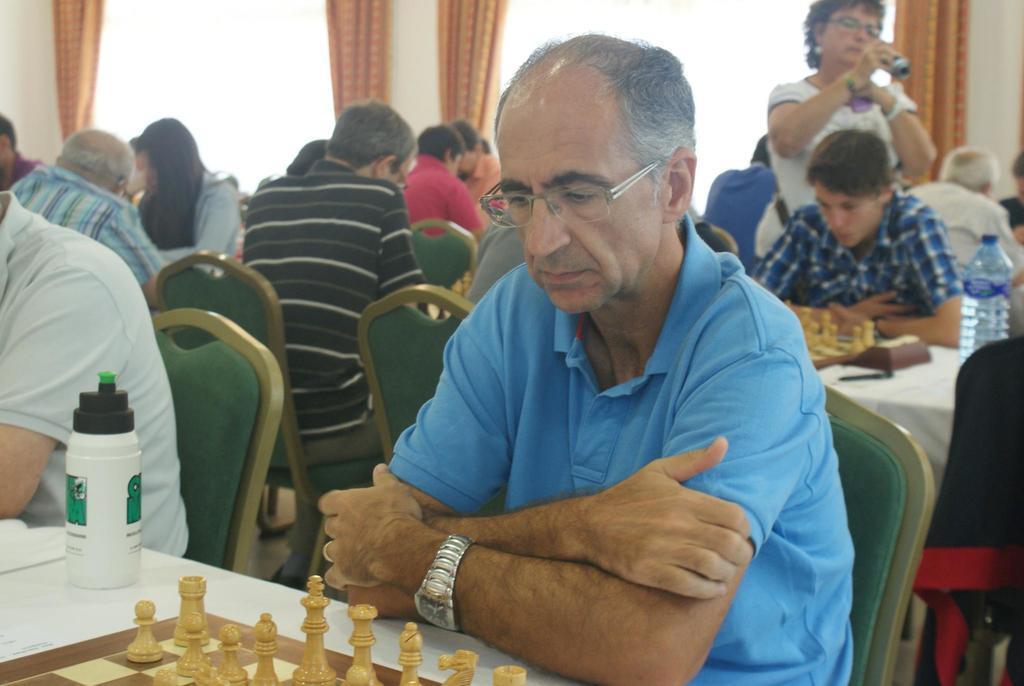Describe this image in one or two sentences. In this picture we can see many people sitting on chair and playing chess and in front of them there are tables and on table we can see chess boards, bottles and here the woman holding camera and in background we can see curtain. 